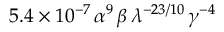Convert formula to latex. <formula><loc_0><loc_0><loc_500><loc_500>5 . 4 \times 1 0 ^ { - 7 } \, \alpha ^ { 9 } \, \beta \, \lambda ^ { - 2 3 / 1 0 } \, \gamma ^ { - 4 }</formula> 